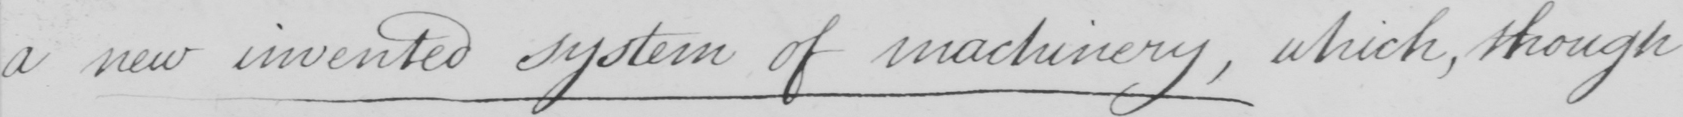Please transcribe the handwritten text in this image. a new invented system of machinery  , which , though 